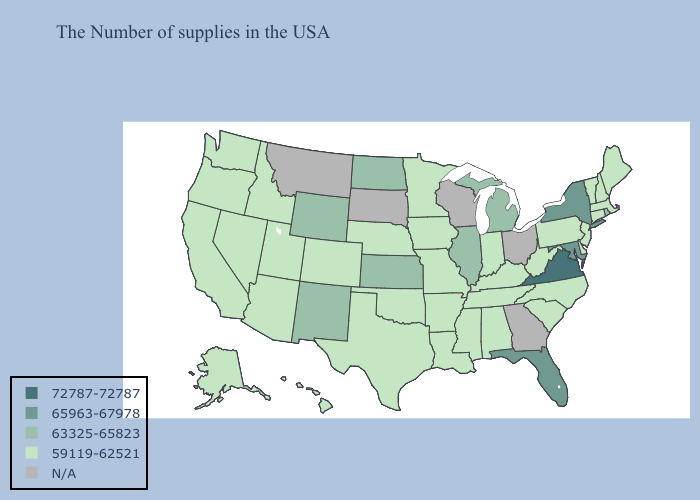Which states have the lowest value in the Northeast?
Concise answer only. Maine, Massachusetts, New Hampshire, Vermont, Connecticut, New Jersey, Pennsylvania. Does Virginia have the lowest value in the South?
Quick response, please. No. Does Arizona have the lowest value in the USA?
Write a very short answer. Yes. Is the legend a continuous bar?
Answer briefly. No. Does the first symbol in the legend represent the smallest category?
Quick response, please. No. Does Virginia have the highest value in the USA?
Be succinct. Yes. Among the states that border Tennessee , does Virginia have the lowest value?
Give a very brief answer. No. Does the first symbol in the legend represent the smallest category?
Give a very brief answer. No. What is the lowest value in the USA?
Write a very short answer. 59119-62521. What is the value of Delaware?
Be succinct. 59119-62521. Which states hav the highest value in the South?
Write a very short answer. Virginia. Does Kansas have the lowest value in the USA?
Concise answer only. No. Name the states that have a value in the range 63325-65823?
Give a very brief answer. Rhode Island, Michigan, Illinois, Kansas, North Dakota, Wyoming, New Mexico. 